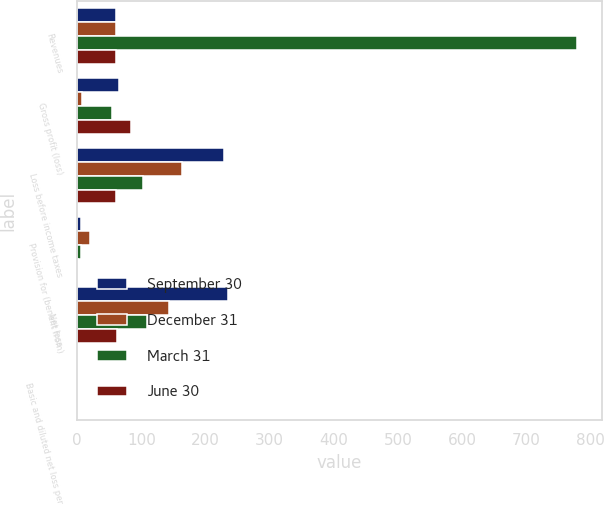Convert chart to OTSL. <chart><loc_0><loc_0><loc_500><loc_500><stacked_bar_chart><ecel><fcel>Revenues<fcel>Gross profit (loss)<fcel>Loss before income taxes<fcel>Provision for (benefit from)<fcel>Net loss<fcel>Basic and diluted net loss per<nl><fcel>September 30<fcel>61.3<fcel>65.2<fcel>229.1<fcel>5.8<fcel>234.9<fcel>0.74<nl><fcel>December 31<fcel>61.3<fcel>8.4<fcel>163.3<fcel>19.6<fcel>143.7<fcel>0.45<nl><fcel>March 31<fcel>778<fcel>55<fcel>103<fcel>5.6<fcel>108.6<fcel>0.34<nl><fcel>June 30<fcel>61.3<fcel>83.7<fcel>61.3<fcel>1.3<fcel>62.6<fcel>0.2<nl></chart> 